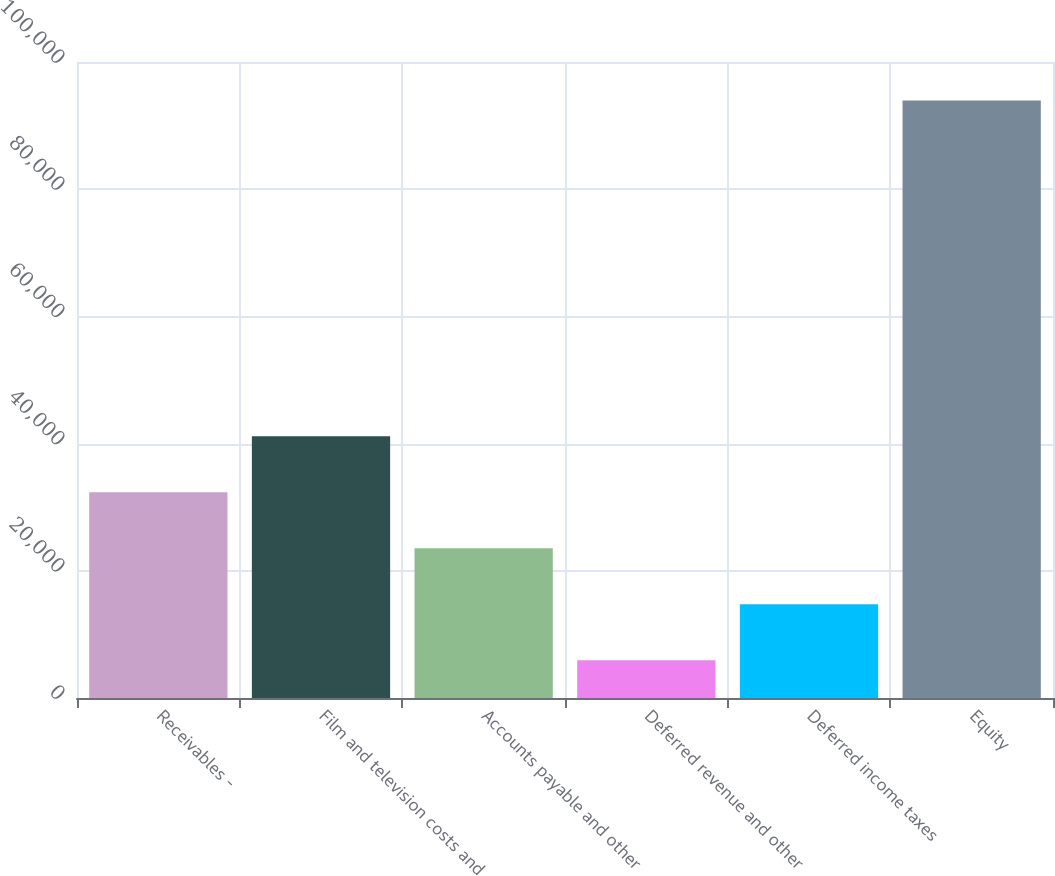Convert chart. <chart><loc_0><loc_0><loc_500><loc_500><bar_chart><fcel>Receivables -<fcel>Film and television costs and<fcel>Accounts payable and other<fcel>Deferred revenue and other<fcel>Deferred income taxes<fcel>Equity<nl><fcel>32345.5<fcel>41144<fcel>23547<fcel>5950<fcel>14748.5<fcel>93935<nl></chart> 